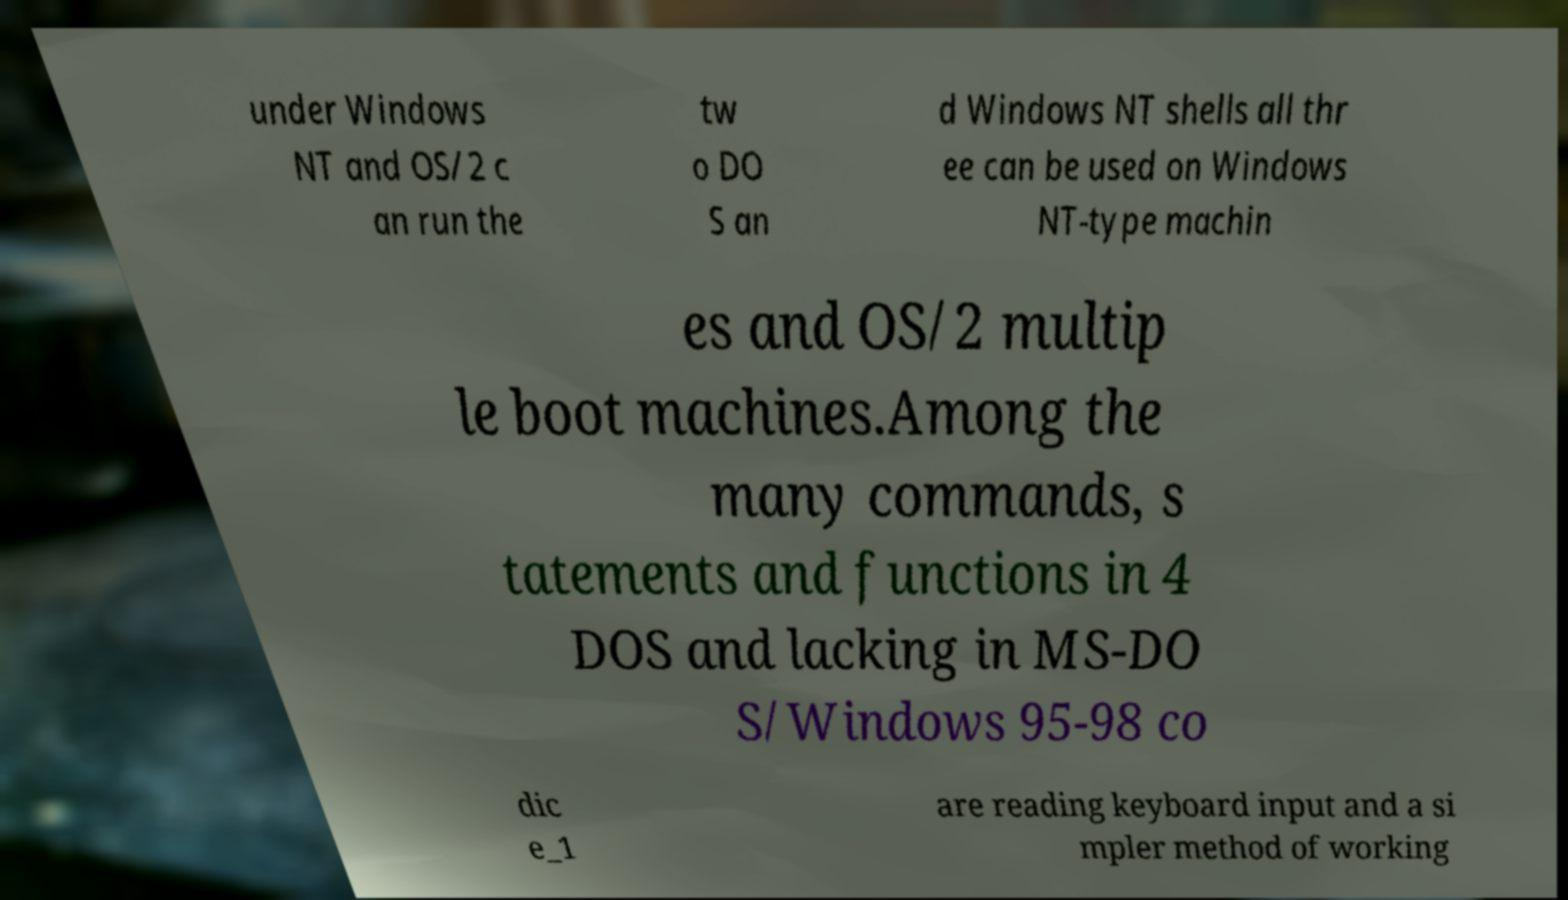Please read and relay the text visible in this image. What does it say? under Windows NT and OS/2 c an run the tw o DO S an d Windows NT shells all thr ee can be used on Windows NT-type machin es and OS/2 multip le boot machines.Among the many commands, s tatements and functions in 4 DOS and lacking in MS-DO S/Windows 95-98 co dic e_1 are reading keyboard input and a si mpler method of working 